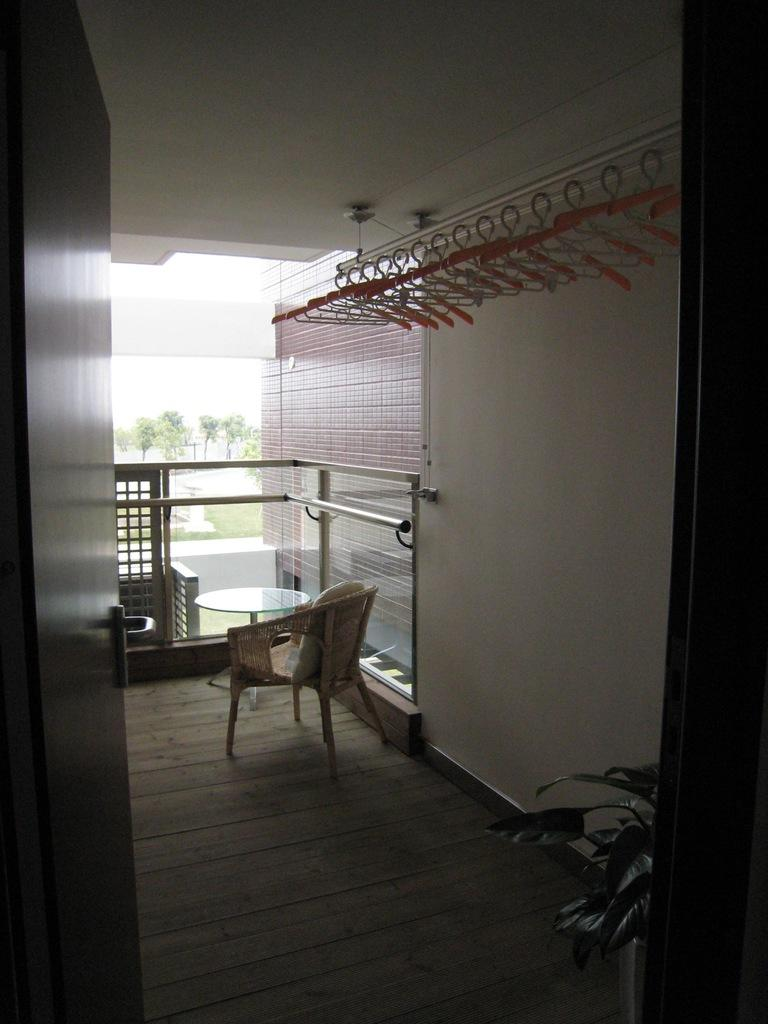What type of furniture is present in the image? There is a table and a chair in the image. What architectural feature can be seen in the image? There is a wall in the image. What type of barrier is visible in the image? There is fencing in the image. What is used for hanging items in the image? There are hangers in the image. What type of entrance is present in the image? There is a door in the image. What type of vegetation is visible in the image? There are trees in the image. What part of the natural environment is visible in the image? The sky is visible in the image. Can you tell me how many chin straps are visible on the trees in the image? There are no chin straps present in the image; it features a table, chair, wall, fencing, hangers, door, trees, and sky. What type of notebook is being used by the person in the image? There is no person or notebook present in the image. 